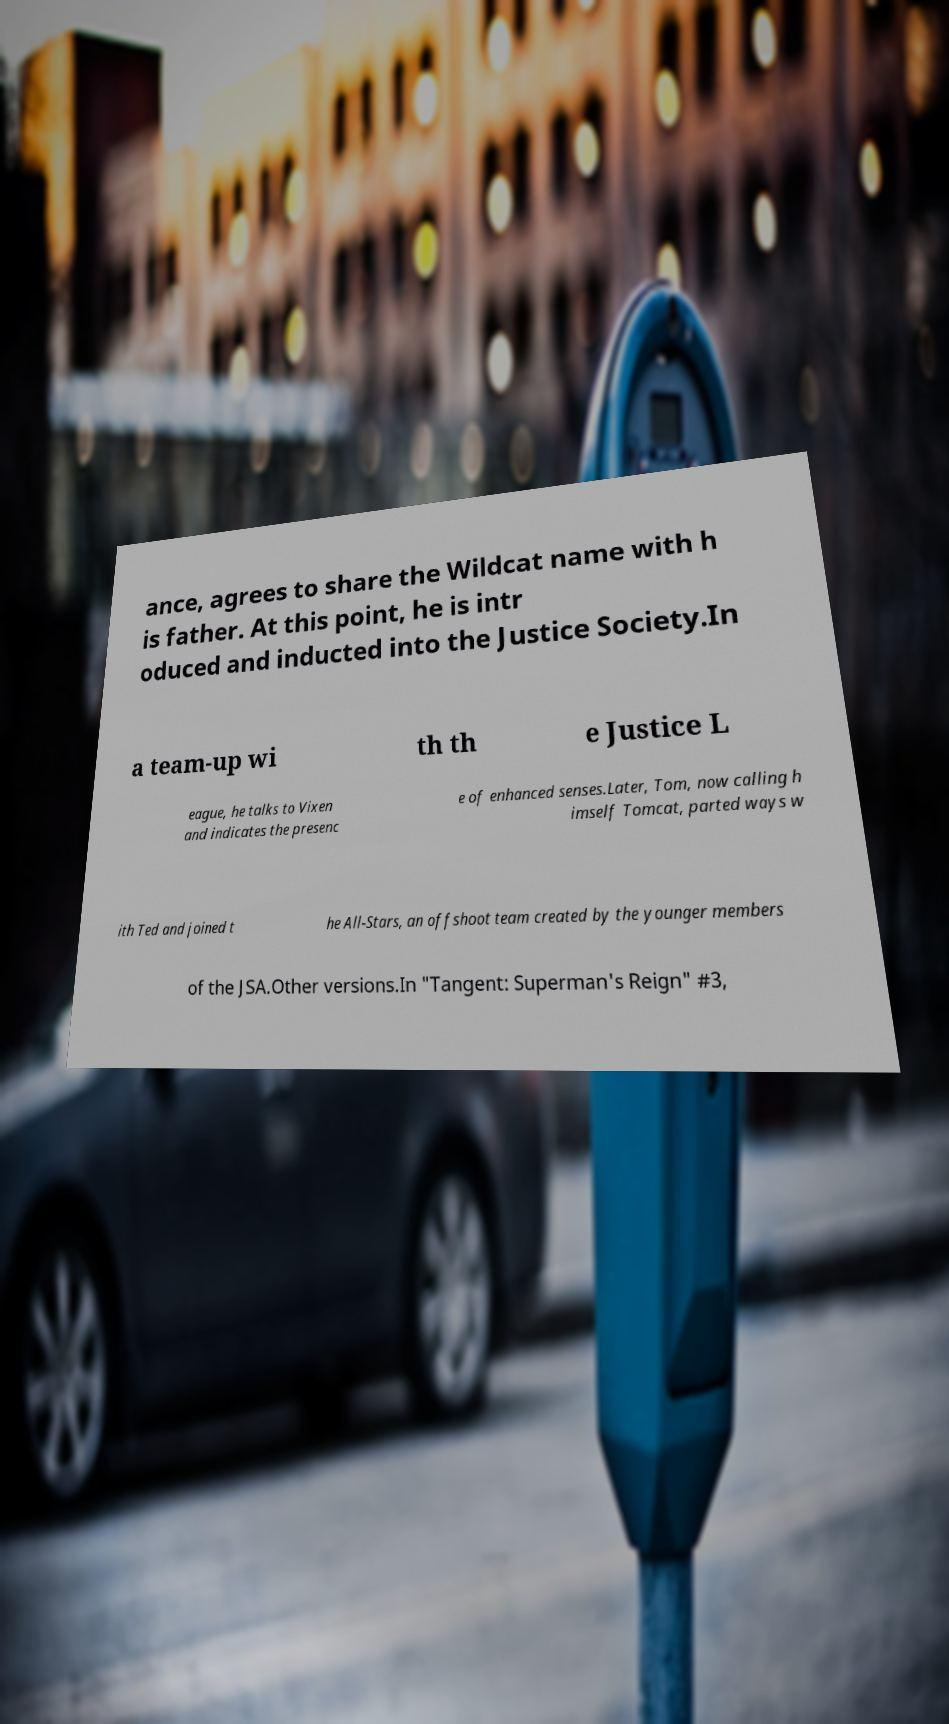Can you accurately transcribe the text from the provided image for me? ance, agrees to share the Wildcat name with h is father. At this point, he is intr oduced and inducted into the Justice Society.In a team-up wi th th e Justice L eague, he talks to Vixen and indicates the presenc e of enhanced senses.Later, Tom, now calling h imself Tomcat, parted ways w ith Ted and joined t he All-Stars, an offshoot team created by the younger members of the JSA.Other versions.In "Tangent: Superman's Reign" #3, 